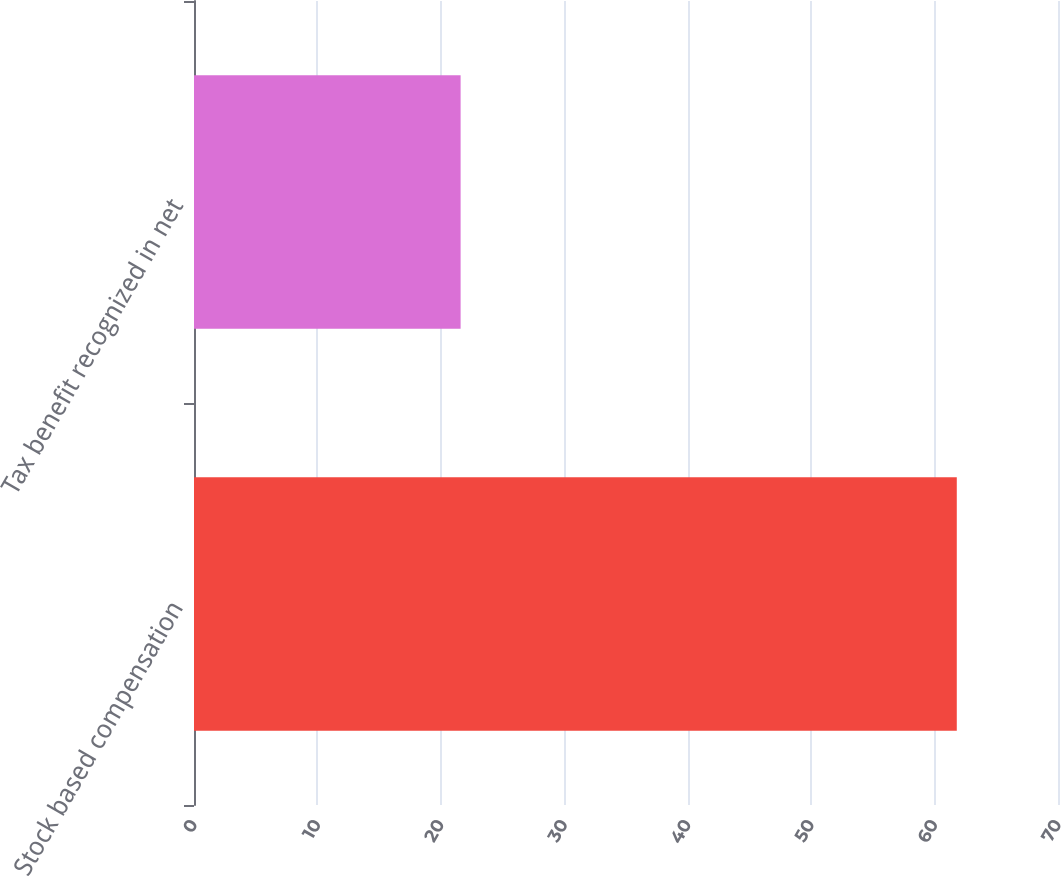Convert chart. <chart><loc_0><loc_0><loc_500><loc_500><bar_chart><fcel>Stock based compensation<fcel>Tax benefit recognized in net<nl><fcel>61.8<fcel>21.6<nl></chart> 